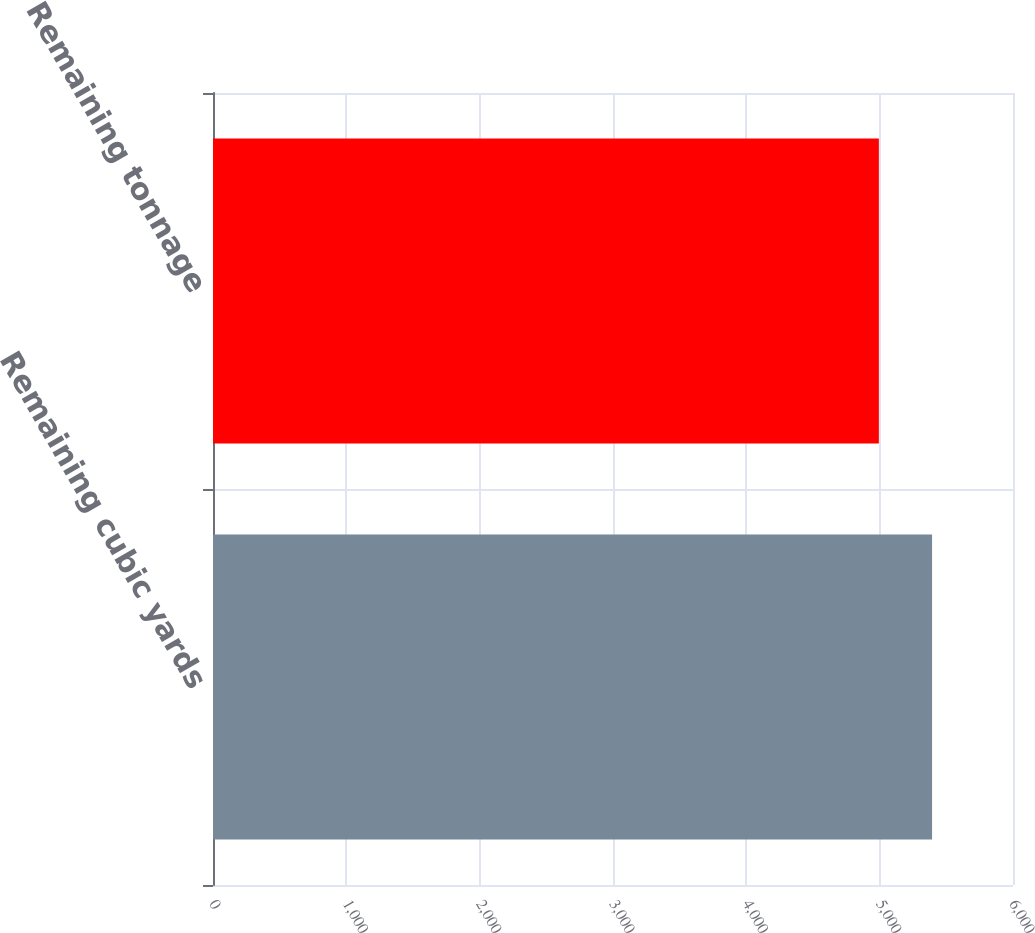Convert chart. <chart><loc_0><loc_0><loc_500><loc_500><bar_chart><fcel>Remaining cubic yards<fcel>Remaining tonnage<nl><fcel>5393<fcel>4994<nl></chart> 